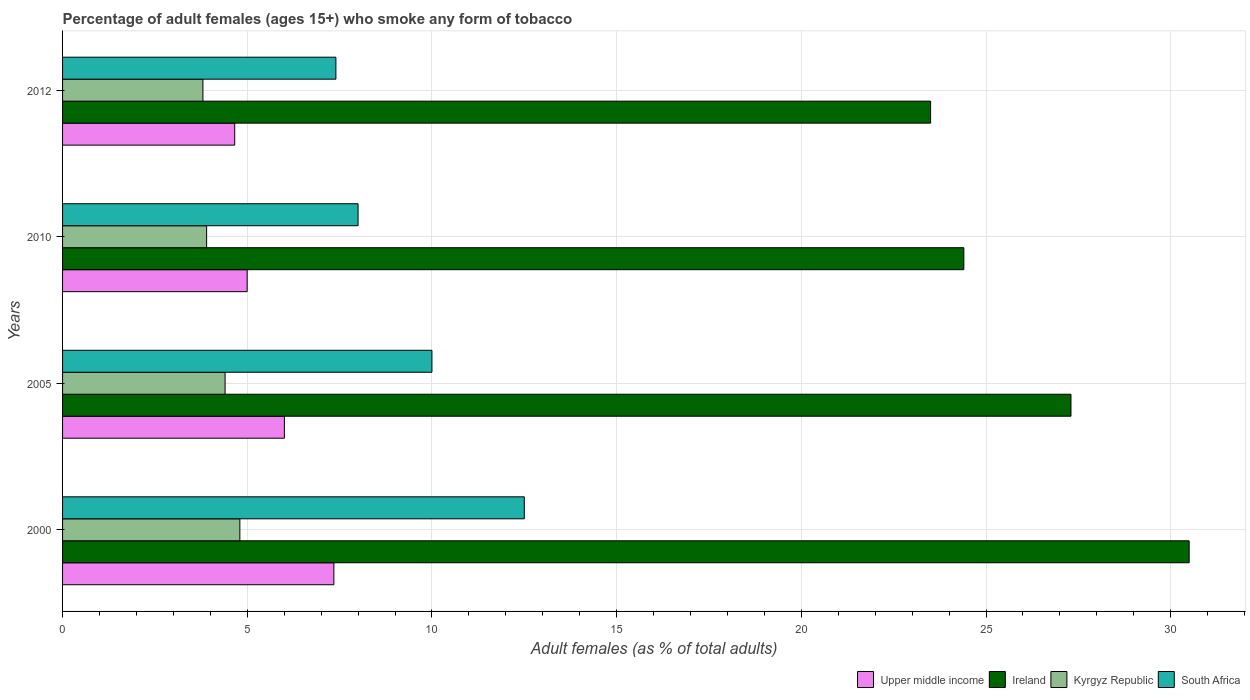Are the number of bars per tick equal to the number of legend labels?
Provide a succinct answer. Yes. How many bars are there on the 1st tick from the top?
Offer a terse response. 4. In how many cases, is the number of bars for a given year not equal to the number of legend labels?
Offer a terse response. 0. What is the percentage of adult females who smoke in Kyrgyz Republic in 2010?
Keep it short and to the point. 3.9. Across all years, what is the maximum percentage of adult females who smoke in Ireland?
Make the answer very short. 30.5. What is the difference between the percentage of adult females who smoke in South Africa in 2005 and that in 2010?
Provide a succinct answer. 2. What is the difference between the percentage of adult females who smoke in South Africa in 2000 and the percentage of adult females who smoke in Ireland in 2012?
Provide a succinct answer. -11. What is the average percentage of adult females who smoke in Ireland per year?
Give a very brief answer. 26.42. In the year 2010, what is the difference between the percentage of adult females who smoke in South Africa and percentage of adult females who smoke in Ireland?
Ensure brevity in your answer.  -16.4. What is the ratio of the percentage of adult females who smoke in Kyrgyz Republic in 2000 to that in 2005?
Your answer should be compact. 1.09. Is the percentage of adult females who smoke in Kyrgyz Republic in 2000 less than that in 2010?
Keep it short and to the point. No. Is the difference between the percentage of adult females who smoke in South Africa in 2010 and 2012 greater than the difference between the percentage of adult females who smoke in Ireland in 2010 and 2012?
Give a very brief answer. No. What is the difference between the highest and the lowest percentage of adult females who smoke in Ireland?
Offer a very short reply. 7. Is it the case that in every year, the sum of the percentage of adult females who smoke in South Africa and percentage of adult females who smoke in Kyrgyz Republic is greater than the sum of percentage of adult females who smoke in Ireland and percentage of adult females who smoke in Upper middle income?
Your response must be concise. No. What does the 2nd bar from the top in 2005 represents?
Offer a terse response. Kyrgyz Republic. What does the 4th bar from the bottom in 2012 represents?
Give a very brief answer. South Africa. Is it the case that in every year, the sum of the percentage of adult females who smoke in South Africa and percentage of adult females who smoke in Ireland is greater than the percentage of adult females who smoke in Kyrgyz Republic?
Provide a short and direct response. Yes. How many bars are there?
Keep it short and to the point. 16. How many years are there in the graph?
Provide a short and direct response. 4. Does the graph contain any zero values?
Offer a terse response. No. Does the graph contain grids?
Provide a short and direct response. Yes. Where does the legend appear in the graph?
Ensure brevity in your answer.  Bottom right. What is the title of the graph?
Provide a succinct answer. Percentage of adult females (ages 15+) who smoke any form of tobacco. What is the label or title of the X-axis?
Ensure brevity in your answer.  Adult females (as % of total adults). What is the Adult females (as % of total adults) in Upper middle income in 2000?
Offer a very short reply. 7.35. What is the Adult females (as % of total adults) of Ireland in 2000?
Your answer should be compact. 30.5. What is the Adult females (as % of total adults) in Kyrgyz Republic in 2000?
Make the answer very short. 4.8. What is the Adult females (as % of total adults) in South Africa in 2000?
Provide a short and direct response. 12.5. What is the Adult females (as % of total adults) in Upper middle income in 2005?
Your answer should be very brief. 6.01. What is the Adult females (as % of total adults) of Ireland in 2005?
Your response must be concise. 27.3. What is the Adult females (as % of total adults) in Upper middle income in 2010?
Provide a short and direct response. 5. What is the Adult females (as % of total adults) in Ireland in 2010?
Give a very brief answer. 24.4. What is the Adult females (as % of total adults) in Kyrgyz Republic in 2010?
Make the answer very short. 3.9. What is the Adult females (as % of total adults) in South Africa in 2010?
Ensure brevity in your answer.  8. What is the Adult females (as % of total adults) of Upper middle income in 2012?
Offer a very short reply. 4.66. What is the Adult females (as % of total adults) of Kyrgyz Republic in 2012?
Offer a very short reply. 3.8. Across all years, what is the maximum Adult females (as % of total adults) in Upper middle income?
Provide a short and direct response. 7.35. Across all years, what is the maximum Adult females (as % of total adults) of Ireland?
Provide a short and direct response. 30.5. Across all years, what is the maximum Adult females (as % of total adults) of Kyrgyz Republic?
Provide a succinct answer. 4.8. Across all years, what is the maximum Adult females (as % of total adults) in South Africa?
Your response must be concise. 12.5. Across all years, what is the minimum Adult females (as % of total adults) in Upper middle income?
Your answer should be very brief. 4.66. Across all years, what is the minimum Adult females (as % of total adults) in Kyrgyz Republic?
Ensure brevity in your answer.  3.8. Across all years, what is the minimum Adult females (as % of total adults) of South Africa?
Your answer should be compact. 7.4. What is the total Adult females (as % of total adults) in Upper middle income in the graph?
Provide a short and direct response. 23.01. What is the total Adult females (as % of total adults) of Ireland in the graph?
Offer a terse response. 105.7. What is the total Adult females (as % of total adults) of Kyrgyz Republic in the graph?
Offer a very short reply. 16.9. What is the total Adult females (as % of total adults) of South Africa in the graph?
Give a very brief answer. 37.9. What is the difference between the Adult females (as % of total adults) of Upper middle income in 2000 and that in 2005?
Your response must be concise. 1.34. What is the difference between the Adult females (as % of total adults) in Kyrgyz Republic in 2000 and that in 2005?
Provide a succinct answer. 0.4. What is the difference between the Adult females (as % of total adults) of South Africa in 2000 and that in 2005?
Offer a very short reply. 2.5. What is the difference between the Adult females (as % of total adults) in Upper middle income in 2000 and that in 2010?
Provide a succinct answer. 2.35. What is the difference between the Adult females (as % of total adults) in Upper middle income in 2000 and that in 2012?
Make the answer very short. 2.68. What is the difference between the Adult females (as % of total adults) of Kyrgyz Republic in 2000 and that in 2012?
Provide a short and direct response. 1. What is the difference between the Adult females (as % of total adults) of South Africa in 2000 and that in 2012?
Give a very brief answer. 5.1. What is the difference between the Adult females (as % of total adults) of Upper middle income in 2005 and that in 2010?
Offer a terse response. 1.01. What is the difference between the Adult females (as % of total adults) of Ireland in 2005 and that in 2010?
Offer a terse response. 2.9. What is the difference between the Adult females (as % of total adults) of Kyrgyz Republic in 2005 and that in 2010?
Provide a short and direct response. 0.5. What is the difference between the Adult females (as % of total adults) of South Africa in 2005 and that in 2010?
Offer a very short reply. 2. What is the difference between the Adult females (as % of total adults) of Upper middle income in 2005 and that in 2012?
Give a very brief answer. 1.34. What is the difference between the Adult females (as % of total adults) of Kyrgyz Republic in 2005 and that in 2012?
Offer a terse response. 0.6. What is the difference between the Adult females (as % of total adults) of South Africa in 2005 and that in 2012?
Provide a short and direct response. 2.6. What is the difference between the Adult females (as % of total adults) in Upper middle income in 2010 and that in 2012?
Ensure brevity in your answer.  0.34. What is the difference between the Adult females (as % of total adults) of Ireland in 2010 and that in 2012?
Provide a short and direct response. 0.9. What is the difference between the Adult females (as % of total adults) in Kyrgyz Republic in 2010 and that in 2012?
Offer a terse response. 0.1. What is the difference between the Adult females (as % of total adults) in Upper middle income in 2000 and the Adult females (as % of total adults) in Ireland in 2005?
Ensure brevity in your answer.  -19.95. What is the difference between the Adult females (as % of total adults) in Upper middle income in 2000 and the Adult females (as % of total adults) in Kyrgyz Republic in 2005?
Offer a very short reply. 2.94. What is the difference between the Adult females (as % of total adults) of Upper middle income in 2000 and the Adult females (as % of total adults) of South Africa in 2005?
Offer a terse response. -2.65. What is the difference between the Adult females (as % of total adults) of Ireland in 2000 and the Adult females (as % of total adults) of Kyrgyz Republic in 2005?
Offer a terse response. 26.1. What is the difference between the Adult females (as % of total adults) of Kyrgyz Republic in 2000 and the Adult females (as % of total adults) of South Africa in 2005?
Make the answer very short. -5.2. What is the difference between the Adult females (as % of total adults) of Upper middle income in 2000 and the Adult females (as % of total adults) of Ireland in 2010?
Provide a short and direct response. -17.05. What is the difference between the Adult females (as % of total adults) in Upper middle income in 2000 and the Adult females (as % of total adults) in Kyrgyz Republic in 2010?
Give a very brief answer. 3.44. What is the difference between the Adult females (as % of total adults) of Upper middle income in 2000 and the Adult females (as % of total adults) of South Africa in 2010?
Your response must be concise. -0.66. What is the difference between the Adult females (as % of total adults) in Ireland in 2000 and the Adult females (as % of total adults) in Kyrgyz Republic in 2010?
Offer a terse response. 26.6. What is the difference between the Adult females (as % of total adults) in Ireland in 2000 and the Adult females (as % of total adults) in South Africa in 2010?
Provide a succinct answer. 22.5. What is the difference between the Adult females (as % of total adults) of Kyrgyz Republic in 2000 and the Adult females (as % of total adults) of South Africa in 2010?
Offer a terse response. -3.2. What is the difference between the Adult females (as % of total adults) of Upper middle income in 2000 and the Adult females (as % of total adults) of Ireland in 2012?
Provide a short and direct response. -16.16. What is the difference between the Adult females (as % of total adults) in Upper middle income in 2000 and the Adult females (as % of total adults) in Kyrgyz Republic in 2012?
Your answer should be compact. 3.54. What is the difference between the Adult females (as % of total adults) in Upper middle income in 2000 and the Adult females (as % of total adults) in South Africa in 2012?
Your response must be concise. -0.06. What is the difference between the Adult females (as % of total adults) of Ireland in 2000 and the Adult females (as % of total adults) of Kyrgyz Republic in 2012?
Your response must be concise. 26.7. What is the difference between the Adult females (as % of total adults) in Ireland in 2000 and the Adult females (as % of total adults) in South Africa in 2012?
Offer a very short reply. 23.1. What is the difference between the Adult females (as % of total adults) of Kyrgyz Republic in 2000 and the Adult females (as % of total adults) of South Africa in 2012?
Provide a succinct answer. -2.6. What is the difference between the Adult females (as % of total adults) of Upper middle income in 2005 and the Adult females (as % of total adults) of Ireland in 2010?
Your answer should be very brief. -18.39. What is the difference between the Adult females (as % of total adults) in Upper middle income in 2005 and the Adult females (as % of total adults) in Kyrgyz Republic in 2010?
Your response must be concise. 2.11. What is the difference between the Adult females (as % of total adults) in Upper middle income in 2005 and the Adult females (as % of total adults) in South Africa in 2010?
Give a very brief answer. -1.99. What is the difference between the Adult females (as % of total adults) in Ireland in 2005 and the Adult females (as % of total adults) in Kyrgyz Republic in 2010?
Keep it short and to the point. 23.4. What is the difference between the Adult females (as % of total adults) of Ireland in 2005 and the Adult females (as % of total adults) of South Africa in 2010?
Make the answer very short. 19.3. What is the difference between the Adult females (as % of total adults) in Kyrgyz Republic in 2005 and the Adult females (as % of total adults) in South Africa in 2010?
Give a very brief answer. -3.6. What is the difference between the Adult females (as % of total adults) in Upper middle income in 2005 and the Adult females (as % of total adults) in Ireland in 2012?
Your answer should be compact. -17.49. What is the difference between the Adult females (as % of total adults) in Upper middle income in 2005 and the Adult females (as % of total adults) in Kyrgyz Republic in 2012?
Provide a short and direct response. 2.21. What is the difference between the Adult females (as % of total adults) of Upper middle income in 2005 and the Adult females (as % of total adults) of South Africa in 2012?
Your answer should be compact. -1.39. What is the difference between the Adult females (as % of total adults) of Ireland in 2005 and the Adult females (as % of total adults) of Kyrgyz Republic in 2012?
Provide a succinct answer. 23.5. What is the difference between the Adult females (as % of total adults) of Ireland in 2005 and the Adult females (as % of total adults) of South Africa in 2012?
Provide a short and direct response. 19.9. What is the difference between the Adult females (as % of total adults) in Upper middle income in 2010 and the Adult females (as % of total adults) in Ireland in 2012?
Offer a very short reply. -18.5. What is the difference between the Adult females (as % of total adults) of Upper middle income in 2010 and the Adult females (as % of total adults) of Kyrgyz Republic in 2012?
Make the answer very short. 1.2. What is the difference between the Adult females (as % of total adults) of Upper middle income in 2010 and the Adult females (as % of total adults) of South Africa in 2012?
Offer a very short reply. -2.4. What is the difference between the Adult females (as % of total adults) of Ireland in 2010 and the Adult females (as % of total adults) of Kyrgyz Republic in 2012?
Make the answer very short. 20.6. What is the difference between the Adult females (as % of total adults) of Ireland in 2010 and the Adult females (as % of total adults) of South Africa in 2012?
Make the answer very short. 17. What is the average Adult females (as % of total adults) of Upper middle income per year?
Keep it short and to the point. 5.75. What is the average Adult females (as % of total adults) of Ireland per year?
Offer a very short reply. 26.43. What is the average Adult females (as % of total adults) in Kyrgyz Republic per year?
Provide a short and direct response. 4.22. What is the average Adult females (as % of total adults) of South Africa per year?
Offer a terse response. 9.47. In the year 2000, what is the difference between the Adult females (as % of total adults) in Upper middle income and Adult females (as % of total adults) in Ireland?
Make the answer very short. -23.16. In the year 2000, what is the difference between the Adult females (as % of total adults) of Upper middle income and Adult females (as % of total adults) of Kyrgyz Republic?
Give a very brief answer. 2.54. In the year 2000, what is the difference between the Adult females (as % of total adults) in Upper middle income and Adult females (as % of total adults) in South Africa?
Your response must be concise. -5.16. In the year 2000, what is the difference between the Adult females (as % of total adults) of Ireland and Adult females (as % of total adults) of Kyrgyz Republic?
Make the answer very short. 25.7. In the year 2000, what is the difference between the Adult females (as % of total adults) in Ireland and Adult females (as % of total adults) in South Africa?
Your answer should be compact. 18. In the year 2000, what is the difference between the Adult females (as % of total adults) of Kyrgyz Republic and Adult females (as % of total adults) of South Africa?
Your answer should be compact. -7.7. In the year 2005, what is the difference between the Adult females (as % of total adults) of Upper middle income and Adult females (as % of total adults) of Ireland?
Give a very brief answer. -21.29. In the year 2005, what is the difference between the Adult females (as % of total adults) in Upper middle income and Adult females (as % of total adults) in Kyrgyz Republic?
Make the answer very short. 1.61. In the year 2005, what is the difference between the Adult females (as % of total adults) in Upper middle income and Adult females (as % of total adults) in South Africa?
Keep it short and to the point. -3.99. In the year 2005, what is the difference between the Adult females (as % of total adults) of Ireland and Adult females (as % of total adults) of Kyrgyz Republic?
Ensure brevity in your answer.  22.9. In the year 2010, what is the difference between the Adult females (as % of total adults) of Upper middle income and Adult females (as % of total adults) of Ireland?
Provide a succinct answer. -19.4. In the year 2010, what is the difference between the Adult females (as % of total adults) of Upper middle income and Adult females (as % of total adults) of Kyrgyz Republic?
Keep it short and to the point. 1.1. In the year 2010, what is the difference between the Adult females (as % of total adults) in Upper middle income and Adult females (as % of total adults) in South Africa?
Keep it short and to the point. -3. In the year 2010, what is the difference between the Adult females (as % of total adults) in Ireland and Adult females (as % of total adults) in Kyrgyz Republic?
Provide a succinct answer. 20.5. In the year 2012, what is the difference between the Adult females (as % of total adults) in Upper middle income and Adult females (as % of total adults) in Ireland?
Provide a succinct answer. -18.84. In the year 2012, what is the difference between the Adult females (as % of total adults) of Upper middle income and Adult females (as % of total adults) of Kyrgyz Republic?
Your answer should be very brief. 0.86. In the year 2012, what is the difference between the Adult females (as % of total adults) of Upper middle income and Adult females (as % of total adults) of South Africa?
Your answer should be very brief. -2.74. In the year 2012, what is the difference between the Adult females (as % of total adults) of Ireland and Adult females (as % of total adults) of South Africa?
Provide a short and direct response. 16.1. In the year 2012, what is the difference between the Adult females (as % of total adults) of Kyrgyz Republic and Adult females (as % of total adults) of South Africa?
Offer a terse response. -3.6. What is the ratio of the Adult females (as % of total adults) of Upper middle income in 2000 to that in 2005?
Offer a very short reply. 1.22. What is the ratio of the Adult females (as % of total adults) in Ireland in 2000 to that in 2005?
Give a very brief answer. 1.12. What is the ratio of the Adult females (as % of total adults) of Kyrgyz Republic in 2000 to that in 2005?
Provide a short and direct response. 1.09. What is the ratio of the Adult females (as % of total adults) in Upper middle income in 2000 to that in 2010?
Give a very brief answer. 1.47. What is the ratio of the Adult females (as % of total adults) in Kyrgyz Republic in 2000 to that in 2010?
Your answer should be compact. 1.23. What is the ratio of the Adult females (as % of total adults) in South Africa in 2000 to that in 2010?
Provide a short and direct response. 1.56. What is the ratio of the Adult females (as % of total adults) in Upper middle income in 2000 to that in 2012?
Make the answer very short. 1.58. What is the ratio of the Adult females (as % of total adults) of Ireland in 2000 to that in 2012?
Offer a very short reply. 1.3. What is the ratio of the Adult females (as % of total adults) in Kyrgyz Republic in 2000 to that in 2012?
Offer a very short reply. 1.26. What is the ratio of the Adult females (as % of total adults) in South Africa in 2000 to that in 2012?
Ensure brevity in your answer.  1.69. What is the ratio of the Adult females (as % of total adults) in Upper middle income in 2005 to that in 2010?
Your answer should be compact. 1.2. What is the ratio of the Adult females (as % of total adults) in Ireland in 2005 to that in 2010?
Your answer should be compact. 1.12. What is the ratio of the Adult females (as % of total adults) of Kyrgyz Republic in 2005 to that in 2010?
Keep it short and to the point. 1.13. What is the ratio of the Adult females (as % of total adults) in Upper middle income in 2005 to that in 2012?
Ensure brevity in your answer.  1.29. What is the ratio of the Adult females (as % of total adults) of Ireland in 2005 to that in 2012?
Offer a terse response. 1.16. What is the ratio of the Adult females (as % of total adults) in Kyrgyz Republic in 2005 to that in 2012?
Your response must be concise. 1.16. What is the ratio of the Adult females (as % of total adults) in South Africa in 2005 to that in 2012?
Provide a succinct answer. 1.35. What is the ratio of the Adult females (as % of total adults) in Upper middle income in 2010 to that in 2012?
Make the answer very short. 1.07. What is the ratio of the Adult females (as % of total adults) in Ireland in 2010 to that in 2012?
Provide a succinct answer. 1.04. What is the ratio of the Adult females (as % of total adults) of Kyrgyz Republic in 2010 to that in 2012?
Give a very brief answer. 1.03. What is the ratio of the Adult females (as % of total adults) of South Africa in 2010 to that in 2012?
Your answer should be compact. 1.08. What is the difference between the highest and the second highest Adult females (as % of total adults) of Upper middle income?
Keep it short and to the point. 1.34. What is the difference between the highest and the second highest Adult females (as % of total adults) in Ireland?
Make the answer very short. 3.2. What is the difference between the highest and the second highest Adult females (as % of total adults) in Kyrgyz Republic?
Make the answer very short. 0.4. What is the difference between the highest and the second highest Adult females (as % of total adults) of South Africa?
Make the answer very short. 2.5. What is the difference between the highest and the lowest Adult females (as % of total adults) of Upper middle income?
Provide a succinct answer. 2.68. 